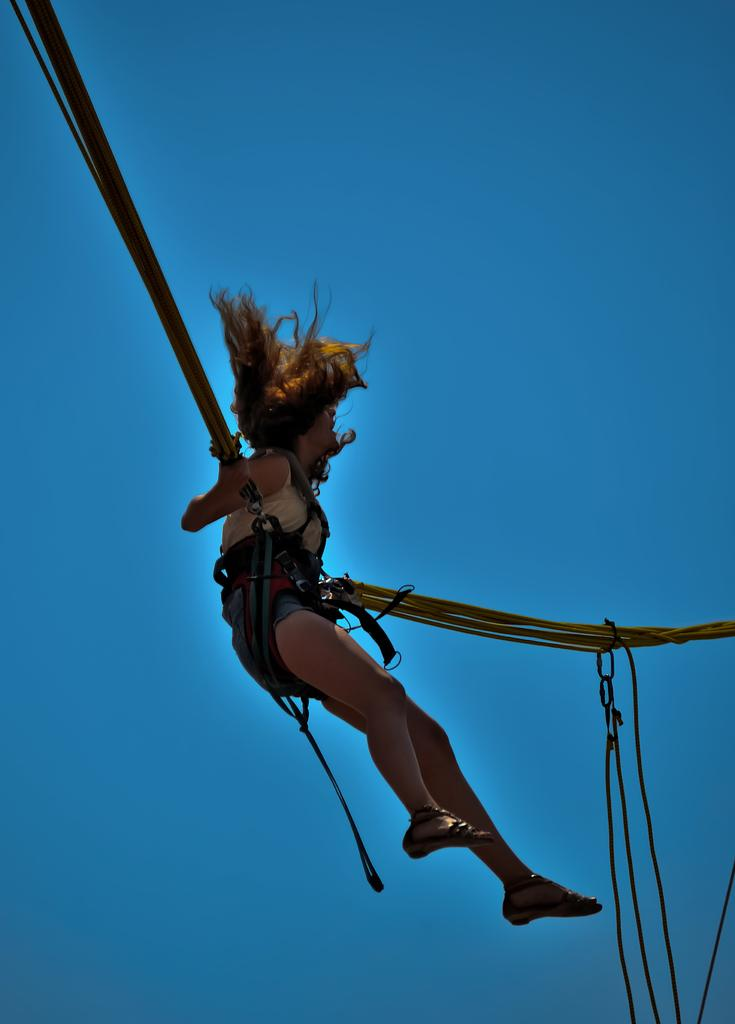Who is the main subject in the image? There is a lady in the image. What is the lady doing in the image? The lady is performing a bungy jump. What can be seen in the background of the image? There is sky visible in the background of the image. What type of harmony is the lady playing on the bungy jump? There is no instrument or music present in the image, so the lady is not playing any type of harmony. 